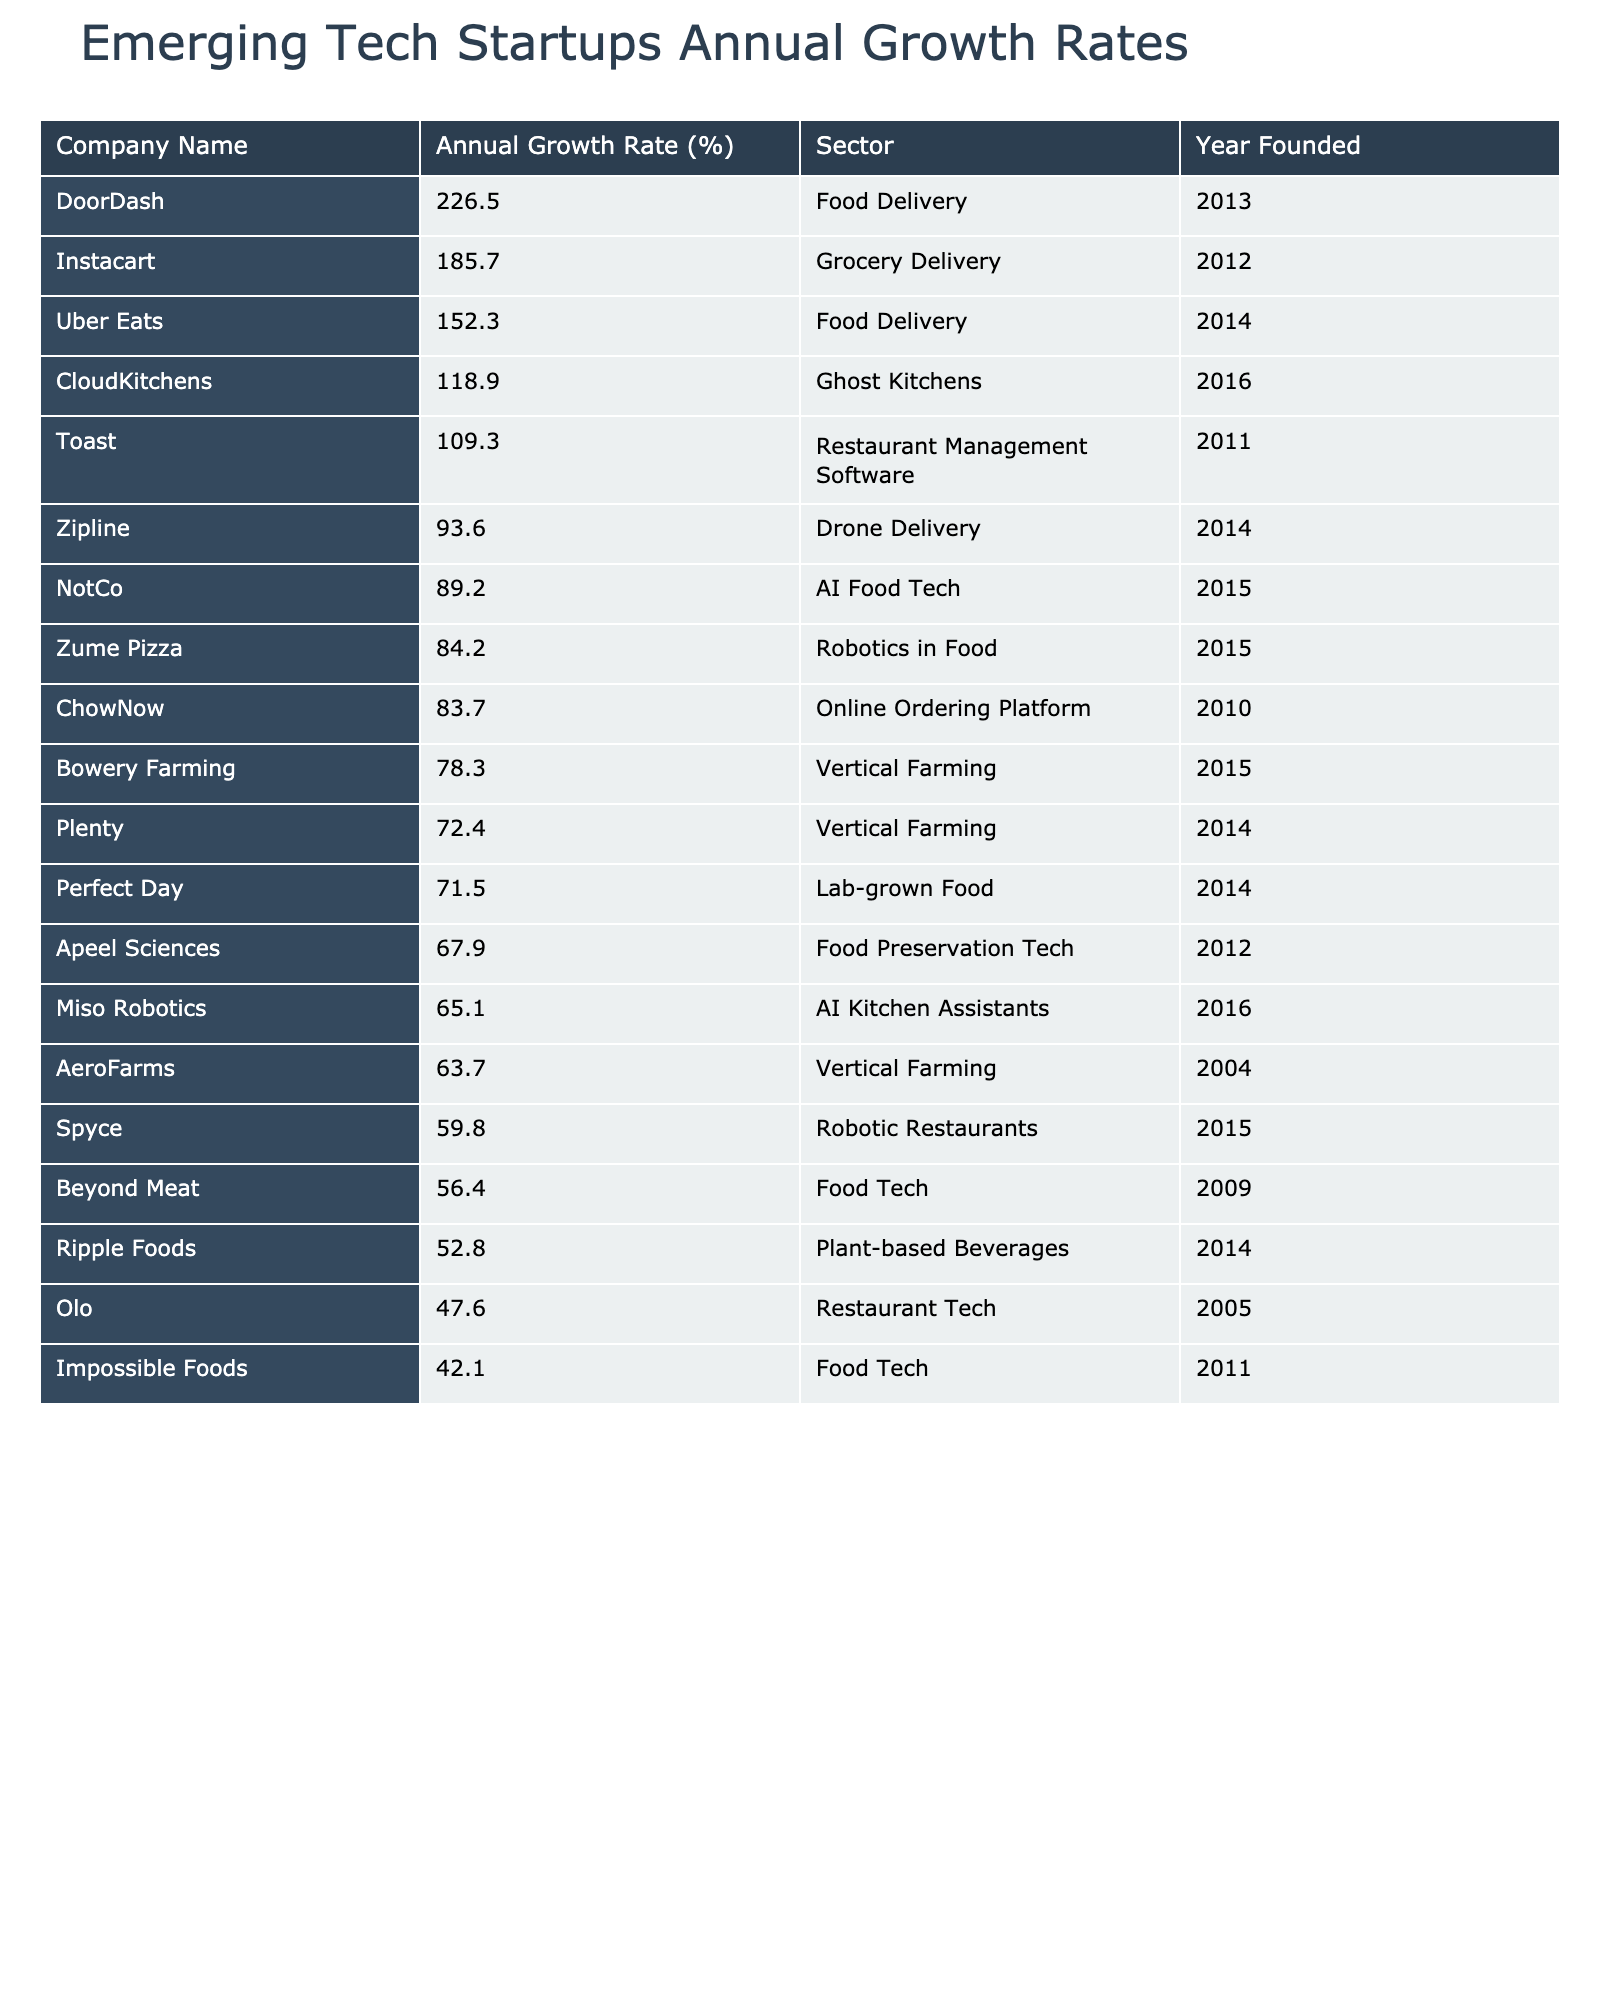What is the annual growth rate of DoorDash? The table lists DoorDash with an annual growth rate of 226.5%.
Answer: 226.5% Which company has the highest annual growth rate? By examining the sorted table, it is clear that DoorDash has the highest annual growth rate at 226.5%.
Answer: DoorDash What is the average annual growth rate of the Food Tech sector? To find the average, we add the annual growth rates of the Food Tech companies (Beyond Meat, Impossible Foods, Ripple Foods) which are 56.4, 42.1, and 52.8 respectively. The total is 151.3. There are 3 companies, so the average is 151.3 / 3 = 50.43.
Answer: 50.43 How many companies in the table were founded after 2015? Looking at the Year Founded column, the companies founded after 2015 are Bowery Farming, NotCo, Perfect Day, Zipline, CloudKitchens, Plenty, and Miso Robotics, totaling 7 companies.
Answer: 7 Is there a company in the AI Food Tech sector with a growth rate above 70%? Yes, NotCo is in the AI Food Tech sector with a growth rate of 89.2%, which is above 70%.
Answer: Yes What is the total annual growth rate of all Vertical Farming companies? The Vertical Farming companies are Bowery Farming (78.3%), AeroFarms (63.7%), and Plenty (72.4%). Their total is 78.3 + 63.7 + 72.4 = 214.4%.
Answer: 214.4% Which company, founded in 2016, has the highest annual growth rate? Miso Robotics (65.1%) and CloudKitchens (118.9%) were both founded in 2016. CloudKitchens has a higher growth rate at 118.9%.
Answer: CloudKitchens What percentage of companies in the table belong to the Food Delivery sector? There are 4 companies in the Food Delivery sector (DoorDash, Uber Eats, Instacart, and CloudKitchens) out of a total of 20 companies, which is 4/20 = 20%.
Answer: 20% Which sector has the company with the lowest growth rate? Olo from the Restaurant Tech sector has the lowest growth rate at 47.6%.
Answer: Restaurant Tech What is the difference in annual growth rates between the highest and lowest company in the Food Tech sector? The highest growth rate in Food Tech is Beyond Meat at 56.4% and the lowest is Ripple Foods at 52.8%. The difference is 56.4 - 52.8 = 3.6%.
Answer: 3.6% 